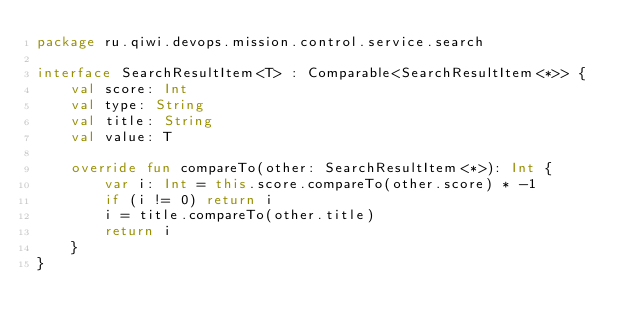Convert code to text. <code><loc_0><loc_0><loc_500><loc_500><_Kotlin_>package ru.qiwi.devops.mission.control.service.search

interface SearchResultItem<T> : Comparable<SearchResultItem<*>> {
    val score: Int
    val type: String
    val title: String
    val value: T

    override fun compareTo(other: SearchResultItem<*>): Int {
        var i: Int = this.score.compareTo(other.score) * -1
        if (i != 0) return i
        i = title.compareTo(other.title)
        return i
    }
}</code> 